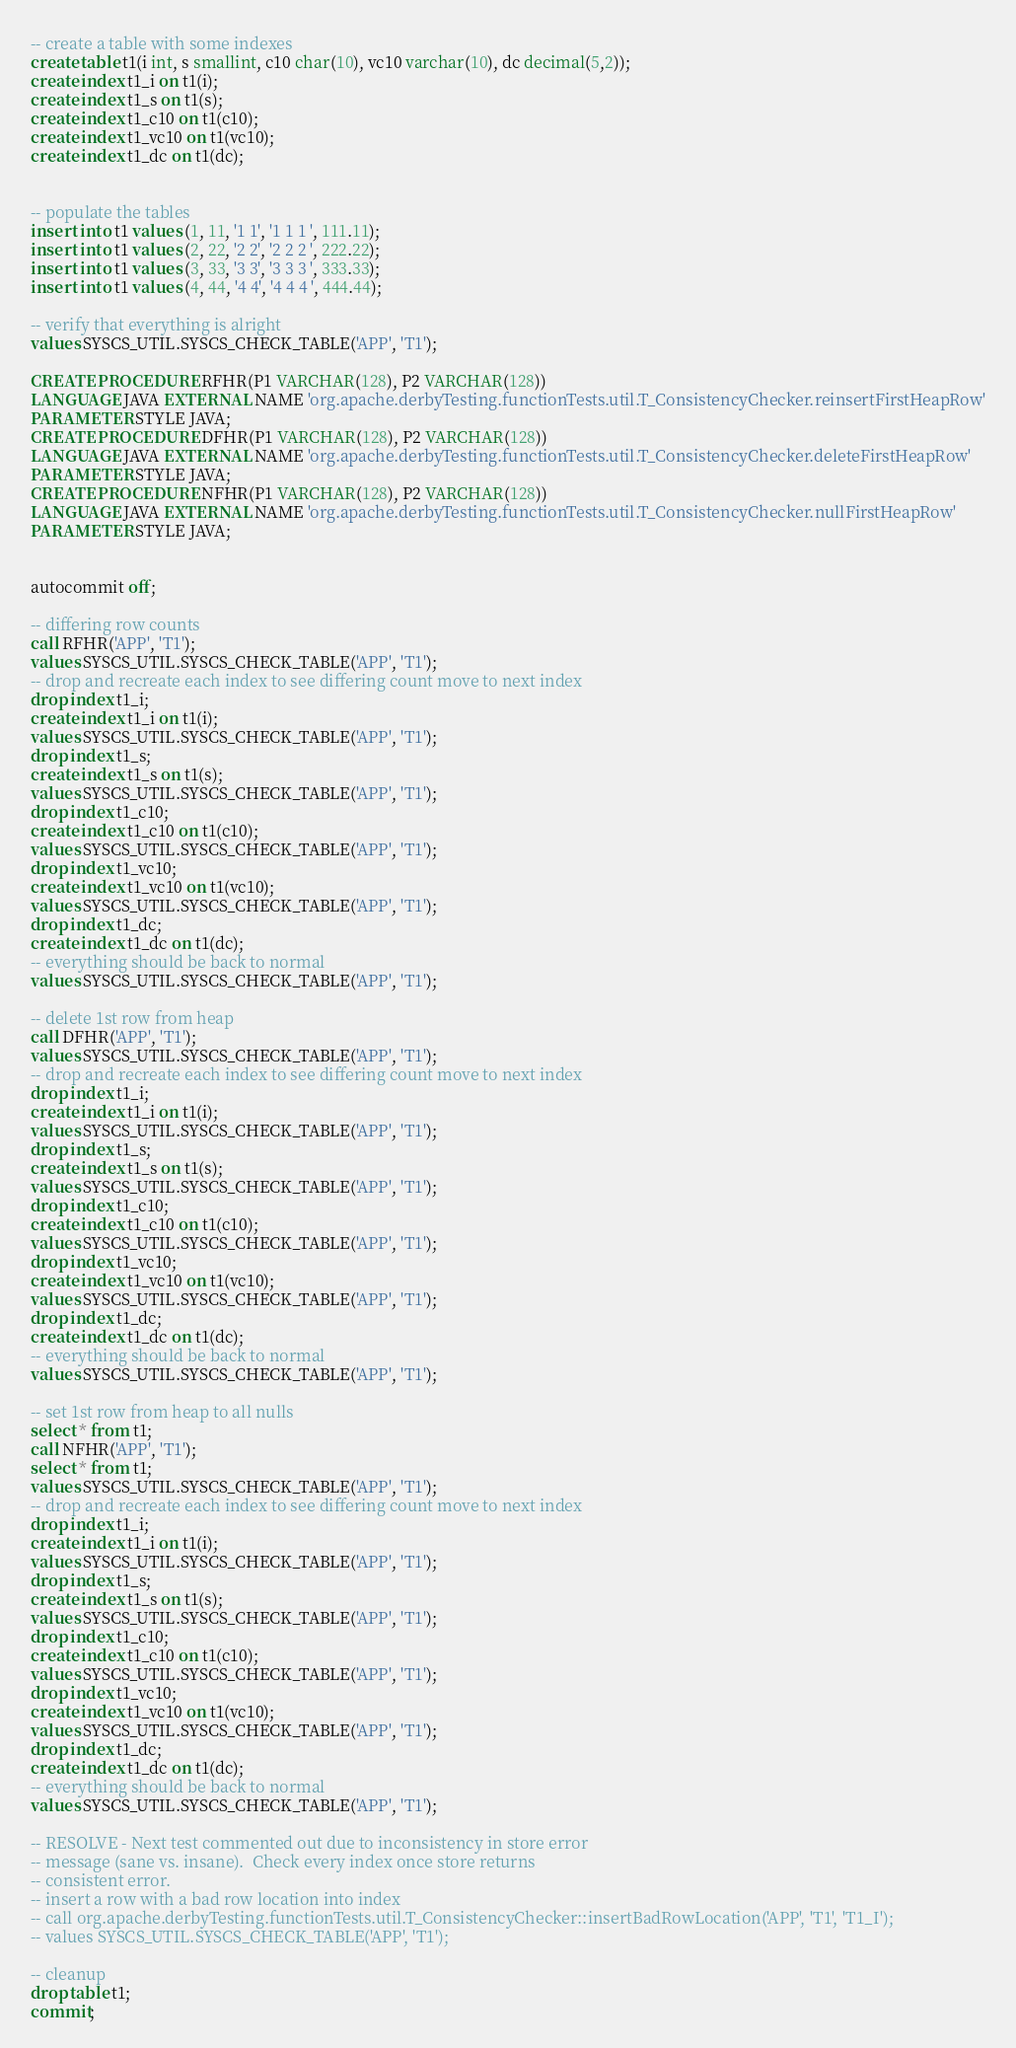<code> <loc_0><loc_0><loc_500><loc_500><_SQL_>
-- create a table with some indexes
create table t1(i int, s smallint, c10 char(10), vc10 varchar(10), dc decimal(5,2));
create index t1_i on t1(i);
create index t1_s on t1(s);
create index t1_c10 on t1(c10);
create index t1_vc10 on t1(vc10);
create index t1_dc on t1(dc);


-- populate the tables
insert into t1 values (1, 11, '1 1', '1 1 1 ', 111.11);
insert into t1 values (2, 22, '2 2', '2 2 2 ', 222.22);
insert into t1 values (3, 33, '3 3', '3 3 3 ', 333.33);
insert into t1 values (4, 44, '4 4', '4 4 4 ', 444.44);

-- verify that everything is alright
values SYSCS_UTIL.SYSCS_CHECK_TABLE('APP', 'T1');

CREATE PROCEDURE RFHR(P1 VARCHAR(128), P2 VARCHAR(128))
LANGUAGE JAVA EXTERNAL NAME 'org.apache.derbyTesting.functionTests.util.T_ConsistencyChecker.reinsertFirstHeapRow'
PARAMETER STYLE JAVA;
CREATE PROCEDURE DFHR(P1 VARCHAR(128), P2 VARCHAR(128))
LANGUAGE JAVA EXTERNAL NAME 'org.apache.derbyTesting.functionTests.util.T_ConsistencyChecker.deleteFirstHeapRow'
PARAMETER STYLE JAVA;
CREATE PROCEDURE NFHR(P1 VARCHAR(128), P2 VARCHAR(128))
LANGUAGE JAVA EXTERNAL NAME 'org.apache.derbyTesting.functionTests.util.T_ConsistencyChecker.nullFirstHeapRow'
PARAMETER STYLE JAVA;


autocommit off;

-- differing row counts
call RFHR('APP', 'T1');
values SYSCS_UTIL.SYSCS_CHECK_TABLE('APP', 'T1');
-- drop and recreate each index to see differing count move to next index
drop index t1_i;
create index t1_i on t1(i);
values SYSCS_UTIL.SYSCS_CHECK_TABLE('APP', 'T1');
drop index t1_s;
create index t1_s on t1(s);
values SYSCS_UTIL.SYSCS_CHECK_TABLE('APP', 'T1');
drop index t1_c10;
create index t1_c10 on t1(c10);
values SYSCS_UTIL.SYSCS_CHECK_TABLE('APP', 'T1');
drop index t1_vc10;
create index t1_vc10 on t1(vc10);
values SYSCS_UTIL.SYSCS_CHECK_TABLE('APP', 'T1');
drop index t1_dc;
create index t1_dc on t1(dc);
-- everything should be back to normal
values SYSCS_UTIL.SYSCS_CHECK_TABLE('APP', 'T1');

-- delete 1st row from heap
call DFHR('APP', 'T1');
values SYSCS_UTIL.SYSCS_CHECK_TABLE('APP', 'T1');
-- drop and recreate each index to see differing count move to next index
drop index t1_i;
create index t1_i on t1(i);
values SYSCS_UTIL.SYSCS_CHECK_TABLE('APP', 'T1');
drop index t1_s;
create index t1_s on t1(s);
values SYSCS_UTIL.SYSCS_CHECK_TABLE('APP', 'T1');
drop index t1_c10;
create index t1_c10 on t1(c10);
values SYSCS_UTIL.SYSCS_CHECK_TABLE('APP', 'T1');
drop index t1_vc10;
create index t1_vc10 on t1(vc10);
values SYSCS_UTIL.SYSCS_CHECK_TABLE('APP', 'T1');
drop index t1_dc;
create index t1_dc on t1(dc);
-- everything should be back to normal
values SYSCS_UTIL.SYSCS_CHECK_TABLE('APP', 'T1');

-- set 1st row from heap to all nulls
select * from t1;
call NFHR('APP', 'T1');
select * from t1;
values SYSCS_UTIL.SYSCS_CHECK_TABLE('APP', 'T1');
-- drop and recreate each index to see differing count move to next index
drop index t1_i;
create index t1_i on t1(i);
values SYSCS_UTIL.SYSCS_CHECK_TABLE('APP', 'T1');
drop index t1_s;
create index t1_s on t1(s);
values SYSCS_UTIL.SYSCS_CHECK_TABLE('APP', 'T1');
drop index t1_c10;
create index t1_c10 on t1(c10);
values SYSCS_UTIL.SYSCS_CHECK_TABLE('APP', 'T1');
drop index t1_vc10;
create index t1_vc10 on t1(vc10);
values SYSCS_UTIL.SYSCS_CHECK_TABLE('APP', 'T1');
drop index t1_dc;
create index t1_dc on t1(dc);
-- everything should be back to normal
values SYSCS_UTIL.SYSCS_CHECK_TABLE('APP', 'T1');

-- RESOLVE - Next test commented out due to inconsistency in store error
-- message (sane vs. insane).  Check every index once store returns
-- consistent error.
-- insert a row with a bad row location into index
-- call org.apache.derbyTesting.functionTests.util.T_ConsistencyChecker::insertBadRowLocation('APP', 'T1', 'T1_I');
-- values SYSCS_UTIL.SYSCS_CHECK_TABLE('APP', 'T1');

-- cleanup
drop table t1;
commit;

</code> 